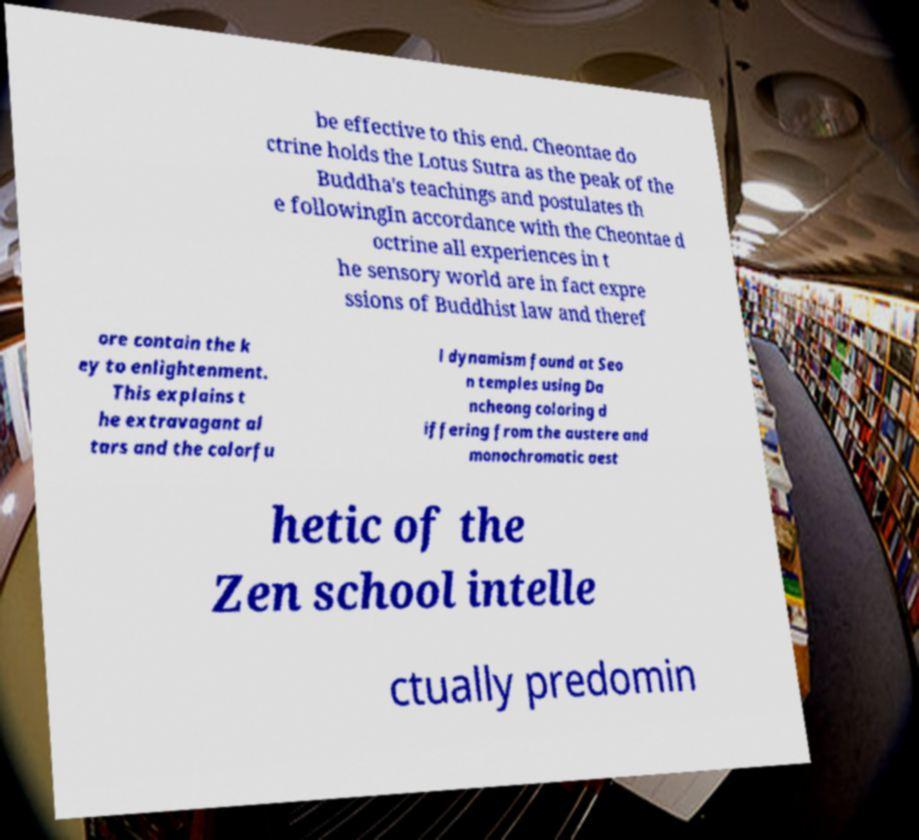What messages or text are displayed in this image? I need them in a readable, typed format. be effective to this end. Cheontae do ctrine holds the Lotus Sutra as the peak of the Buddha's teachings and postulates th e followingIn accordance with the Cheontae d octrine all experiences in t he sensory world are in fact expre ssions of Buddhist law and theref ore contain the k ey to enlightenment. This explains t he extravagant al tars and the colorfu l dynamism found at Seo n temples using Da ncheong coloring d iffering from the austere and monochromatic aest hetic of the Zen school intelle ctually predomin 